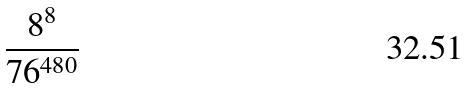Convert formula to latex. <formula><loc_0><loc_0><loc_500><loc_500>\frac { 8 ^ { 8 } } { 7 6 ^ { 4 8 0 } }</formula> 